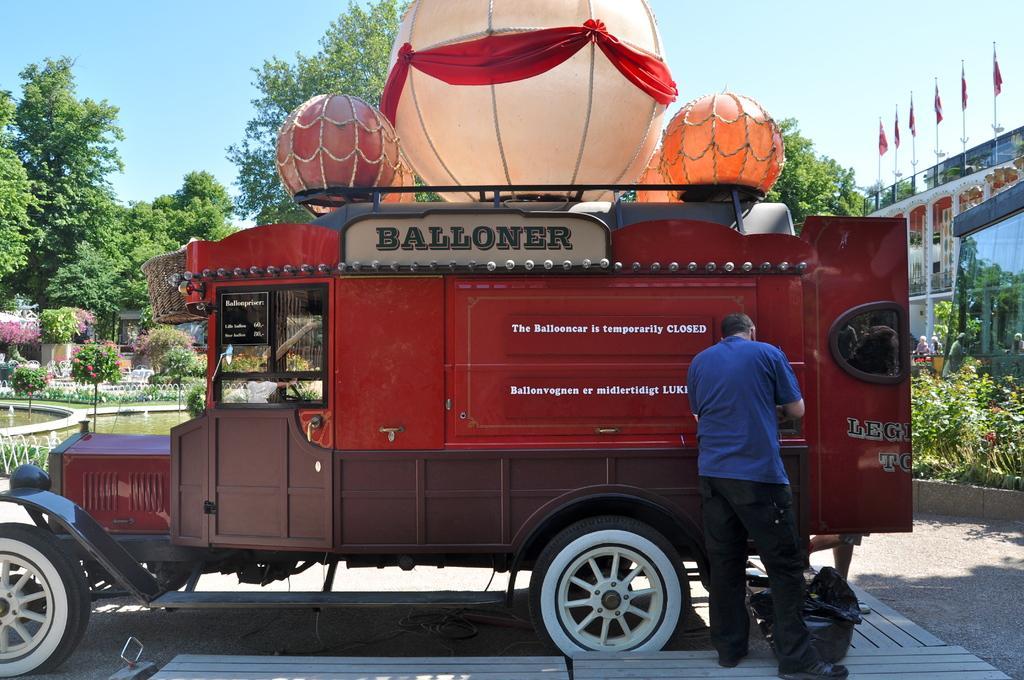In one or two sentences, can you explain what this image depicts? In this picture we can see a man, vehicle, bag, plants, water, trees, flags, some objects and in the background we can see the sky. 